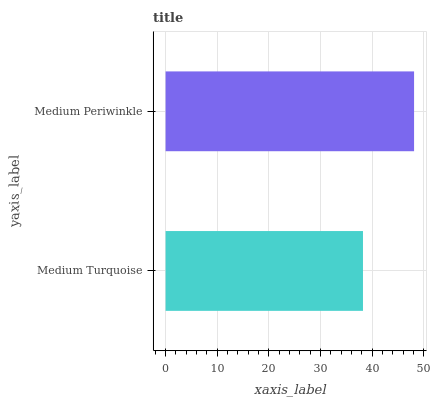Is Medium Turquoise the minimum?
Answer yes or no. Yes. Is Medium Periwinkle the maximum?
Answer yes or no. Yes. Is Medium Periwinkle the minimum?
Answer yes or no. No. Is Medium Periwinkle greater than Medium Turquoise?
Answer yes or no. Yes. Is Medium Turquoise less than Medium Periwinkle?
Answer yes or no. Yes. Is Medium Turquoise greater than Medium Periwinkle?
Answer yes or no. No. Is Medium Periwinkle less than Medium Turquoise?
Answer yes or no. No. Is Medium Periwinkle the high median?
Answer yes or no. Yes. Is Medium Turquoise the low median?
Answer yes or no. Yes. Is Medium Turquoise the high median?
Answer yes or no. No. Is Medium Periwinkle the low median?
Answer yes or no. No. 